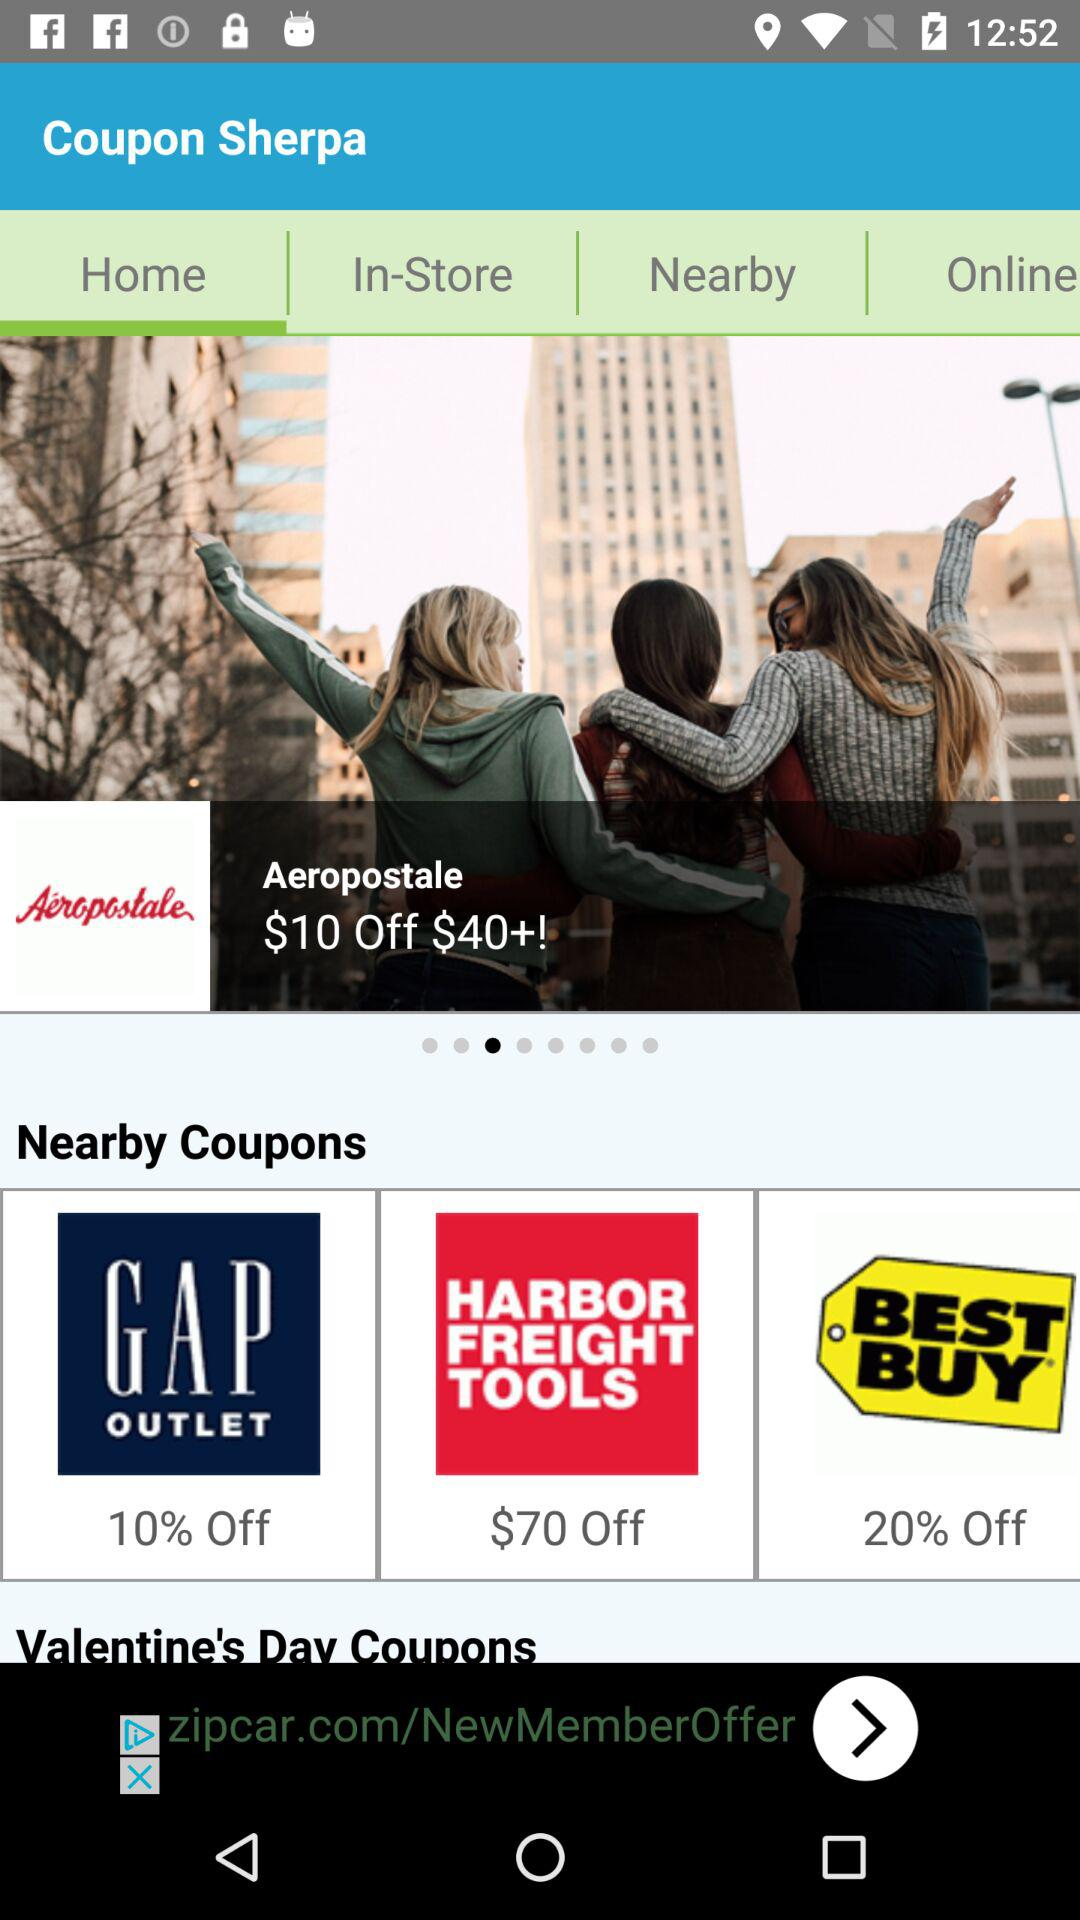How much of the percentage is off on "GAP"? The percentage off on "GAP" is 10. 